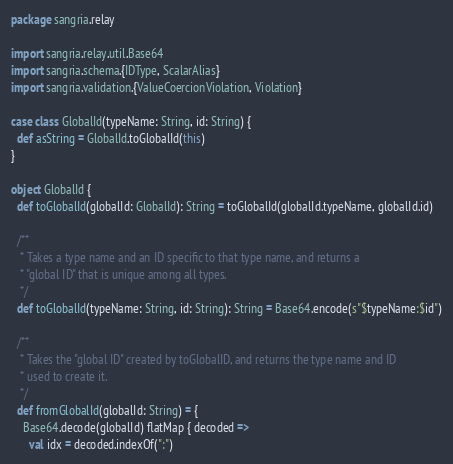<code> <loc_0><loc_0><loc_500><loc_500><_Scala_>package sangria.relay

import sangria.relay.util.Base64
import sangria.schema.{IDType, ScalarAlias}
import sangria.validation.{ValueCoercionViolation, Violation}

case class GlobalId(typeName: String, id: String) {
  def asString = GlobalId.toGlobalId(this)
}

object GlobalId {
  def toGlobalId(globalId: GlobalId): String = toGlobalId(globalId.typeName, globalId.id)

  /**
   * Takes a type name and an ID specific to that type name, and returns a
   * "global ID" that is unique among all types.
   */
  def toGlobalId(typeName: String, id: String): String = Base64.encode(s"$typeName:$id")

  /**
   * Takes the "global ID" created by toGlobalID, and returns the type name and ID
   * used to create it.
   */
  def fromGlobalId(globalId: String) = {
    Base64.decode(globalId) flatMap { decoded =>
      val idx = decoded.indexOf(":")
</code> 